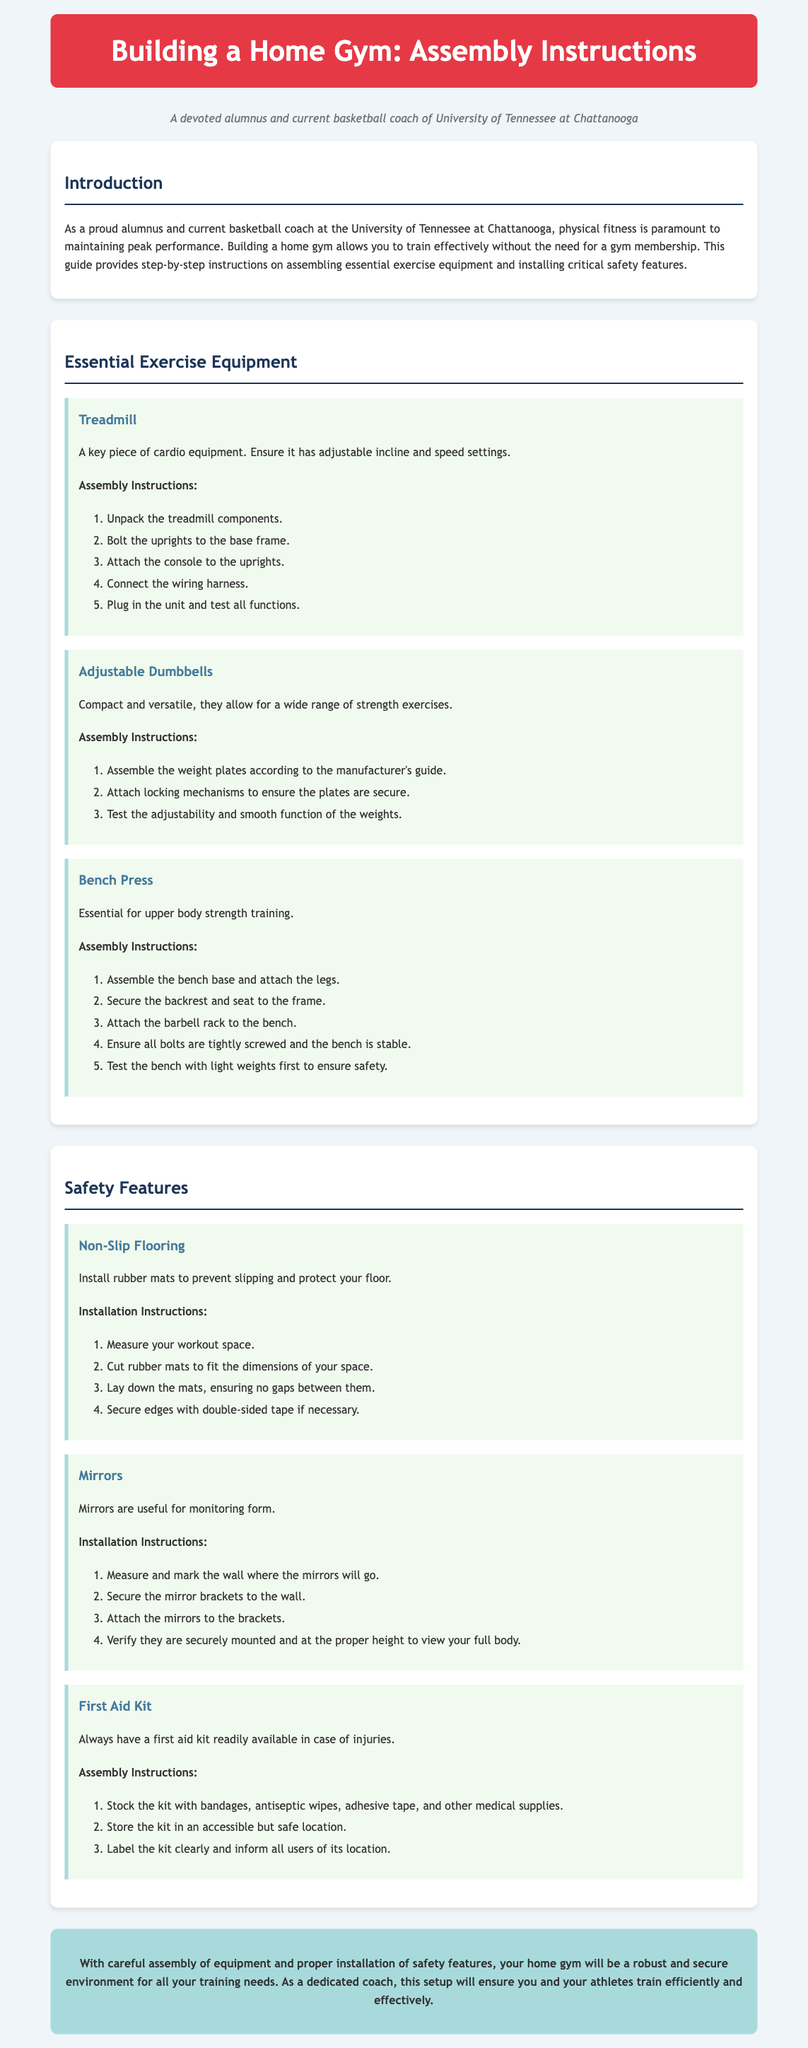what is the title of the document? The title of the document is presented at the top of the page, identifying the guide's focus on building a home gym.
Answer: Building a Home Gym: Assembly Instructions what is the first exercise equipment mentioned? The document lists exercise equipment in a specific order, starting with a treadmill.
Answer: Treadmill how many steps are in the assembly instructions for the bench press? The document outlines the assembly instructions for the bench press in a numbered list which contains five steps.
Answer: 5 what is the last safety feature mentioned? The document concludes the section on safety features with a first aid kit listed last among three features.
Answer: First Aid Kit what do you need to install to prevent slipping? The guide discusses the necessity of installing a specific feature that addresses safety while exercising.
Answer: Non-Slip Flooring what is the main purpose of the mirrors in the home gym? The document states that mirrors are useful for a specific purpose related to workout performance.
Answer: Monitoring form how should the first aid kit be labeled? The document specifies how the first aid kit should be recognized within the gym space for safety and accessibility.
Answer: Clearly what is the background color of the document? The document mentions the color scheme and background details, specifying the color of the content area.
Answer: #f0f5f9 